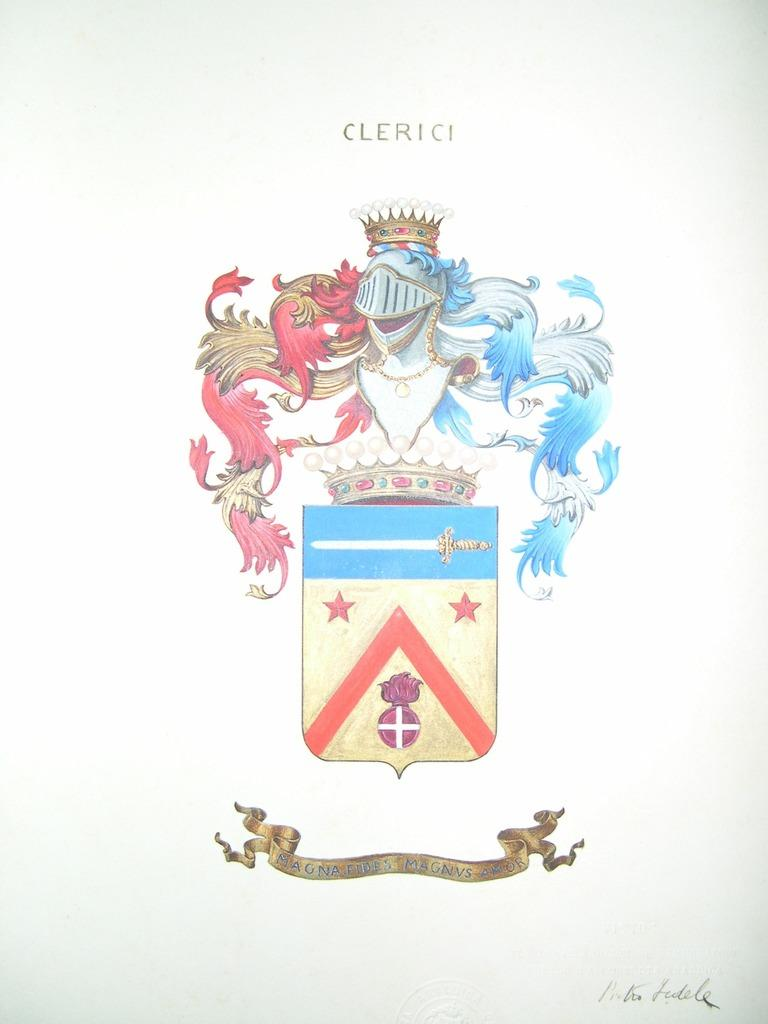What is depicted on the paper in the image? There is a picture on the white color paper in the image. Can you describe the colors used in the picture? The picture is in multicolor. What type of fuel is being used by the nation depicted in the image? There is no nation or fuel mentioned in the image; it only features a picture on white color paper with multicolor. 